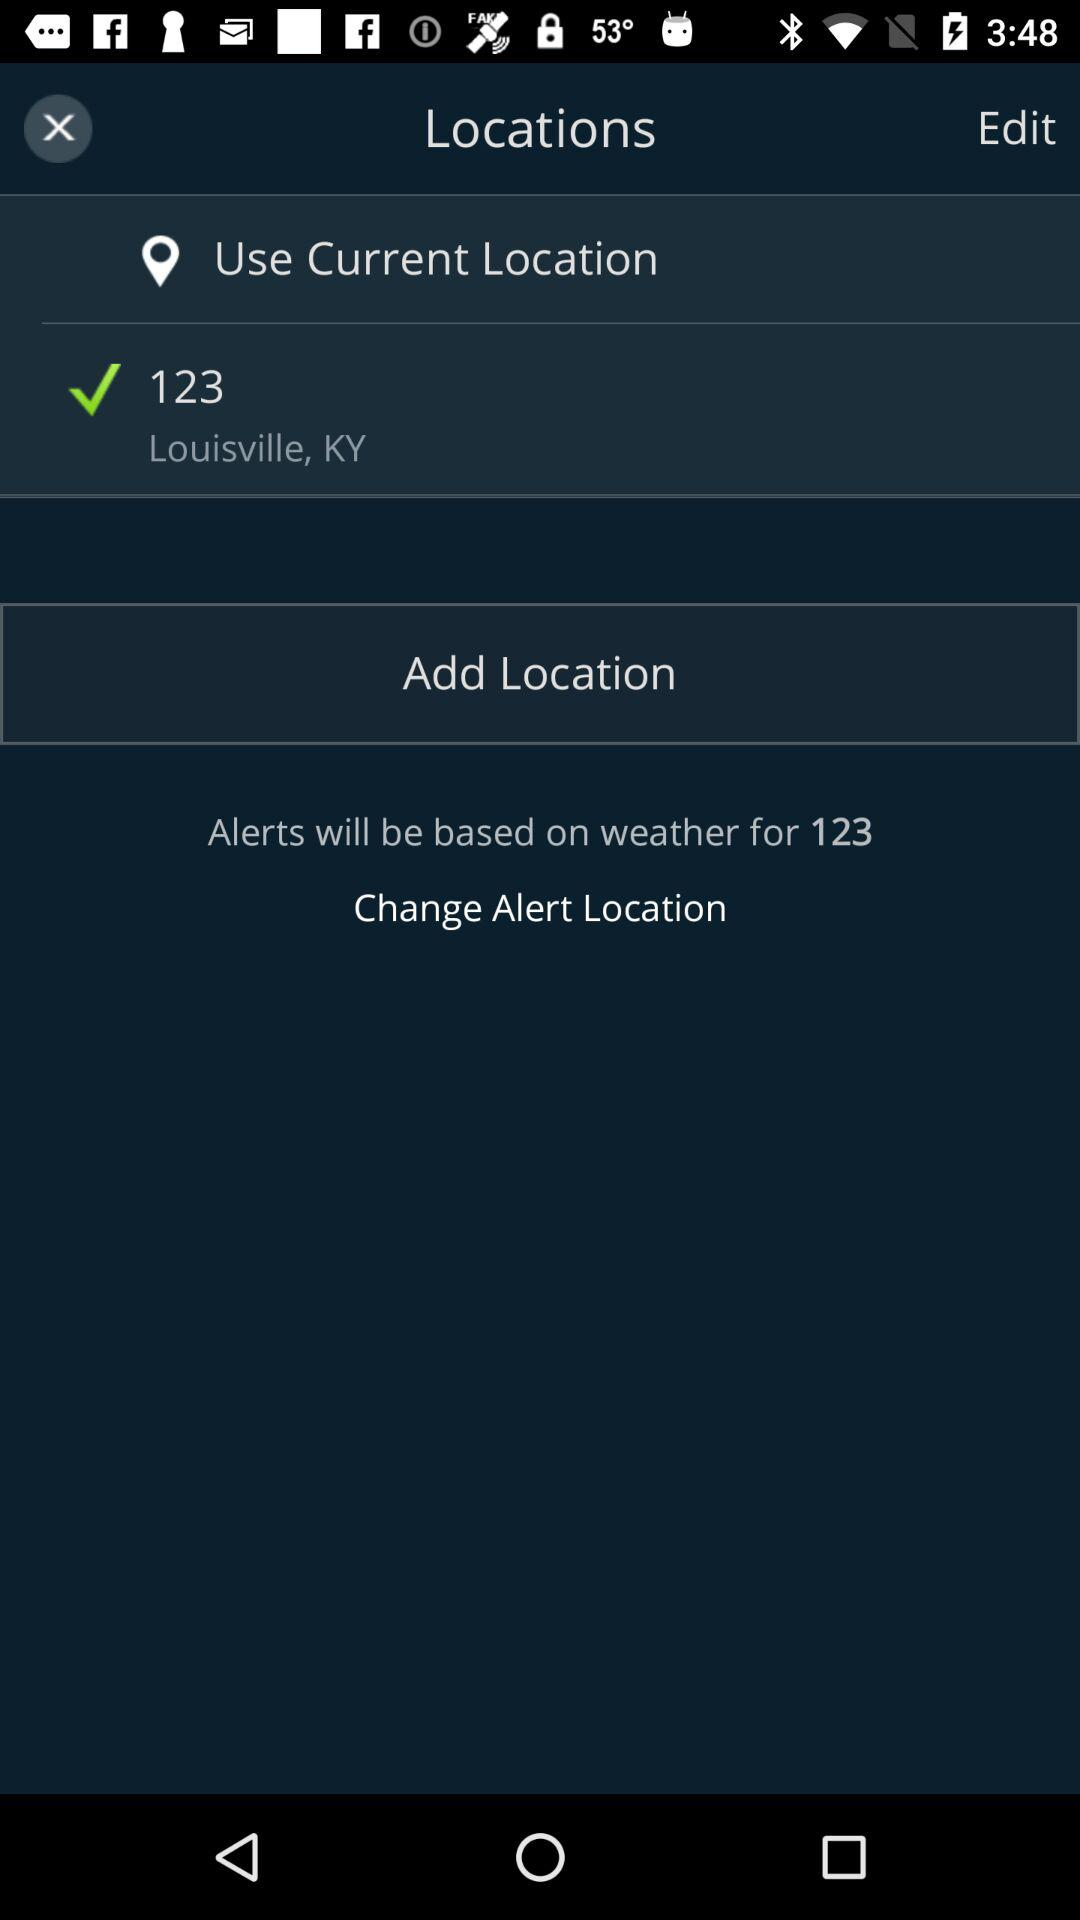What is the mentioned location? The mentioned location is Louisville, KY. 